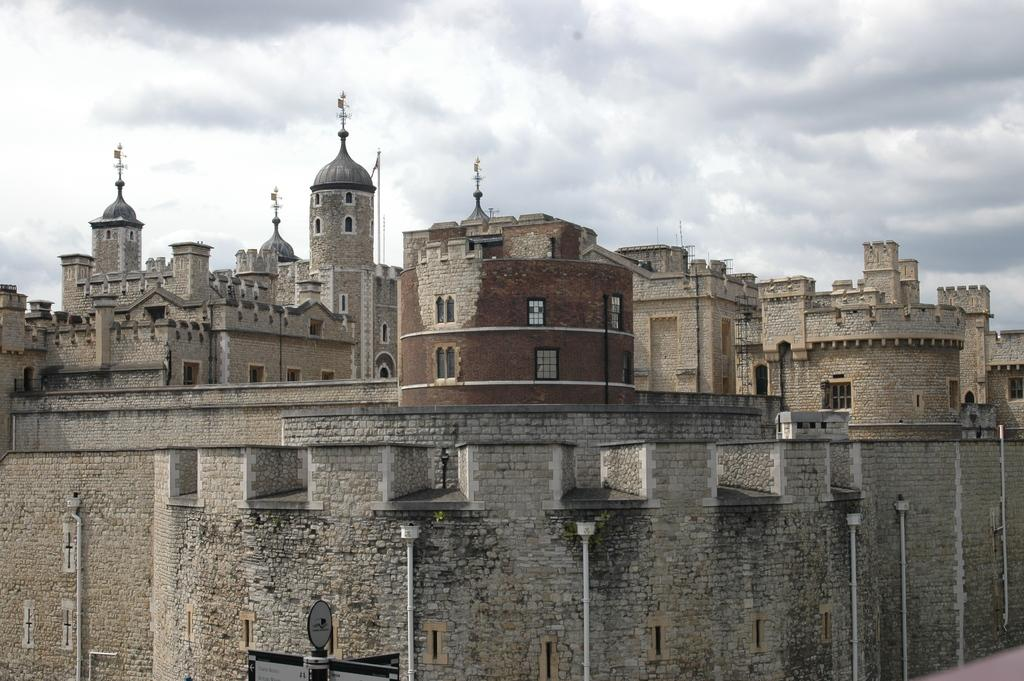What type of structures can be seen in the image? There are buildings in the image. What else is present at the bottom of the image? There are poles and lights at the bottom of the image. Can you describe the unspecified object in the image? Unfortunately, the fact only mentions that there is an unspecified object in the image, so we cannot provide more details about it. What is visible at the top of the image? The sky is visible at the top of the image. What type of skirt is being worn by the territory in the image? There is no territory or skirt present in the image. 